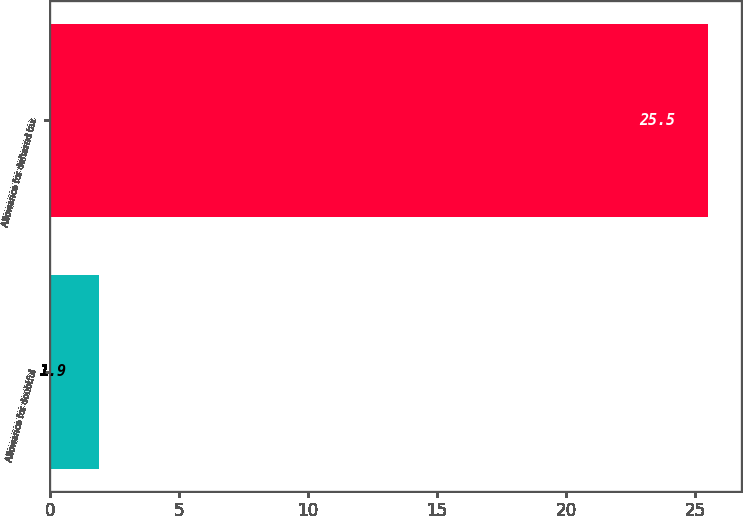<chart> <loc_0><loc_0><loc_500><loc_500><bar_chart><fcel>Allowance for doubtful<fcel>Allowance for deferred tax<nl><fcel>1.9<fcel>25.5<nl></chart> 